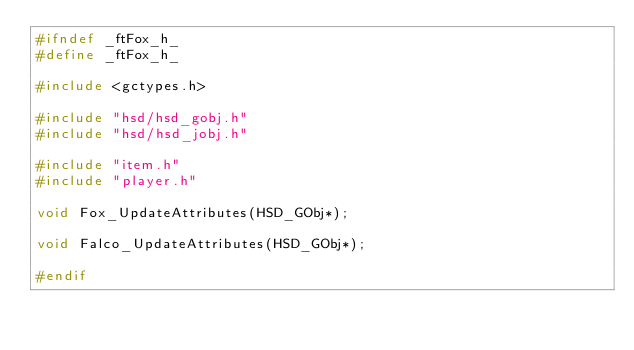<code> <loc_0><loc_0><loc_500><loc_500><_C_>#ifndef _ftFox_h_
#define _ftFox_h_

#include <gctypes.h>

#include "hsd/hsd_gobj.h"
#include "hsd/hsd_jobj.h"

#include "item.h"
#include "player.h"

void Fox_UpdateAttributes(HSD_GObj*);

void Falco_UpdateAttributes(HSD_GObj*);

#endif
</code> 